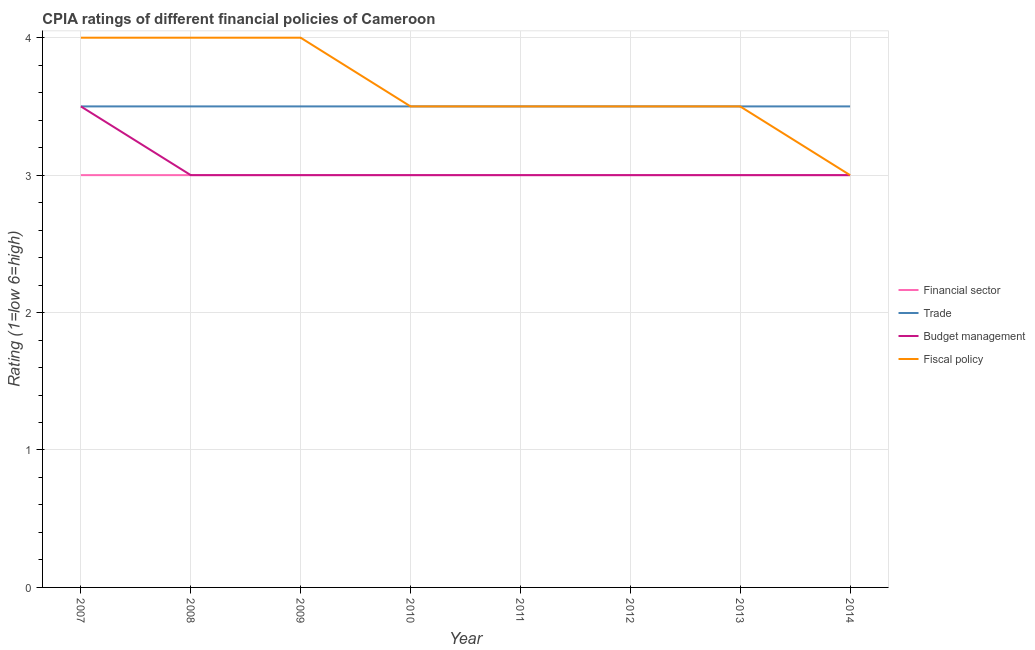How many different coloured lines are there?
Your answer should be very brief. 4. Is the number of lines equal to the number of legend labels?
Ensure brevity in your answer.  Yes. In which year was the cpia rating of financial sector minimum?
Ensure brevity in your answer.  2007. What is the total cpia rating of financial sector in the graph?
Your answer should be very brief. 24. What is the difference between the cpia rating of trade in 2011 and that in 2012?
Offer a terse response. 0. What is the difference between the cpia rating of fiscal policy in 2009 and the cpia rating of budget management in 2008?
Make the answer very short. 1. What is the average cpia rating of fiscal policy per year?
Give a very brief answer. 3.62. In the year 2011, what is the difference between the cpia rating of financial sector and cpia rating of fiscal policy?
Ensure brevity in your answer.  -0.5. In how many years, is the cpia rating of trade greater than 0.8?
Offer a very short reply. 8. What is the ratio of the cpia rating of trade in 2007 to that in 2014?
Provide a short and direct response. 1. Is the cpia rating of fiscal policy in 2007 less than that in 2014?
Offer a terse response. No. What is the difference between the highest and the second highest cpia rating of trade?
Ensure brevity in your answer.  0. Is it the case that in every year, the sum of the cpia rating of fiscal policy and cpia rating of trade is greater than the sum of cpia rating of financial sector and cpia rating of budget management?
Offer a very short reply. No. Is it the case that in every year, the sum of the cpia rating of financial sector and cpia rating of trade is greater than the cpia rating of budget management?
Your response must be concise. Yes. What is the difference between two consecutive major ticks on the Y-axis?
Offer a very short reply. 1. Are the values on the major ticks of Y-axis written in scientific E-notation?
Your answer should be compact. No. Does the graph contain grids?
Make the answer very short. Yes. Where does the legend appear in the graph?
Provide a short and direct response. Center right. How many legend labels are there?
Offer a terse response. 4. What is the title of the graph?
Keep it short and to the point. CPIA ratings of different financial policies of Cameroon. What is the label or title of the X-axis?
Keep it short and to the point. Year. What is the Rating (1=low 6=high) of Trade in 2007?
Keep it short and to the point. 3.5. What is the Rating (1=low 6=high) in Trade in 2008?
Give a very brief answer. 3.5. What is the Rating (1=low 6=high) in Budget management in 2008?
Offer a terse response. 3. What is the Rating (1=low 6=high) in Fiscal policy in 2008?
Keep it short and to the point. 4. What is the Rating (1=low 6=high) in Financial sector in 2009?
Your response must be concise. 3. What is the Rating (1=low 6=high) in Financial sector in 2010?
Provide a succinct answer. 3. What is the Rating (1=low 6=high) of Budget management in 2010?
Your answer should be very brief. 3. What is the Rating (1=low 6=high) in Fiscal policy in 2010?
Ensure brevity in your answer.  3.5. What is the Rating (1=low 6=high) in Trade in 2011?
Provide a succinct answer. 3.5. What is the Rating (1=low 6=high) in Budget management in 2011?
Make the answer very short. 3. What is the Rating (1=low 6=high) in Financial sector in 2012?
Your response must be concise. 3. What is the Rating (1=low 6=high) of Trade in 2012?
Give a very brief answer. 3.5. What is the Rating (1=low 6=high) in Fiscal policy in 2012?
Your response must be concise. 3.5. What is the Rating (1=low 6=high) of Trade in 2013?
Keep it short and to the point. 3.5. What is the Rating (1=low 6=high) of Fiscal policy in 2013?
Your answer should be very brief. 3.5. What is the Rating (1=low 6=high) in Trade in 2014?
Ensure brevity in your answer.  3.5. What is the Rating (1=low 6=high) in Budget management in 2014?
Offer a terse response. 3. Across all years, what is the minimum Rating (1=low 6=high) in Trade?
Ensure brevity in your answer.  3.5. Across all years, what is the minimum Rating (1=low 6=high) in Fiscal policy?
Ensure brevity in your answer.  3. What is the total Rating (1=low 6=high) of Financial sector in the graph?
Ensure brevity in your answer.  24. What is the total Rating (1=low 6=high) of Budget management in the graph?
Your answer should be compact. 24.5. What is the total Rating (1=low 6=high) in Fiscal policy in the graph?
Your answer should be compact. 29. What is the difference between the Rating (1=low 6=high) in Financial sector in 2007 and that in 2008?
Your answer should be compact. 0. What is the difference between the Rating (1=low 6=high) of Fiscal policy in 2007 and that in 2009?
Your response must be concise. 0. What is the difference between the Rating (1=low 6=high) of Fiscal policy in 2007 and that in 2010?
Give a very brief answer. 0.5. What is the difference between the Rating (1=low 6=high) of Financial sector in 2007 and that in 2011?
Provide a succinct answer. 0. What is the difference between the Rating (1=low 6=high) in Budget management in 2007 and that in 2011?
Give a very brief answer. 0.5. What is the difference between the Rating (1=low 6=high) of Financial sector in 2007 and that in 2012?
Your answer should be compact. 0. What is the difference between the Rating (1=low 6=high) in Budget management in 2007 and that in 2012?
Make the answer very short. 0.5. What is the difference between the Rating (1=low 6=high) of Fiscal policy in 2007 and that in 2012?
Your response must be concise. 0.5. What is the difference between the Rating (1=low 6=high) of Financial sector in 2007 and that in 2013?
Your answer should be very brief. 0. What is the difference between the Rating (1=low 6=high) of Financial sector in 2007 and that in 2014?
Your answer should be compact. 0. What is the difference between the Rating (1=low 6=high) in Fiscal policy in 2007 and that in 2014?
Keep it short and to the point. 1. What is the difference between the Rating (1=low 6=high) of Fiscal policy in 2008 and that in 2009?
Provide a succinct answer. 0. What is the difference between the Rating (1=low 6=high) in Financial sector in 2008 and that in 2010?
Offer a terse response. 0. What is the difference between the Rating (1=low 6=high) in Trade in 2008 and that in 2010?
Ensure brevity in your answer.  0. What is the difference between the Rating (1=low 6=high) in Budget management in 2008 and that in 2010?
Keep it short and to the point. 0. What is the difference between the Rating (1=low 6=high) in Trade in 2008 and that in 2011?
Your response must be concise. 0. What is the difference between the Rating (1=low 6=high) of Financial sector in 2008 and that in 2012?
Your answer should be compact. 0. What is the difference between the Rating (1=low 6=high) of Trade in 2008 and that in 2012?
Offer a terse response. 0. What is the difference between the Rating (1=low 6=high) in Budget management in 2008 and that in 2012?
Your answer should be compact. 0. What is the difference between the Rating (1=low 6=high) of Fiscal policy in 2008 and that in 2012?
Your answer should be very brief. 0.5. What is the difference between the Rating (1=low 6=high) of Trade in 2008 and that in 2013?
Offer a very short reply. 0. What is the difference between the Rating (1=low 6=high) of Fiscal policy in 2008 and that in 2013?
Ensure brevity in your answer.  0.5. What is the difference between the Rating (1=low 6=high) in Fiscal policy in 2008 and that in 2014?
Give a very brief answer. 1. What is the difference between the Rating (1=low 6=high) in Trade in 2009 and that in 2010?
Your answer should be compact. 0. What is the difference between the Rating (1=low 6=high) in Budget management in 2009 and that in 2010?
Keep it short and to the point. 0. What is the difference between the Rating (1=low 6=high) in Fiscal policy in 2009 and that in 2010?
Offer a terse response. 0.5. What is the difference between the Rating (1=low 6=high) in Financial sector in 2009 and that in 2011?
Make the answer very short. 0. What is the difference between the Rating (1=low 6=high) of Budget management in 2009 and that in 2011?
Your answer should be very brief. 0. What is the difference between the Rating (1=low 6=high) in Financial sector in 2009 and that in 2012?
Your answer should be compact. 0. What is the difference between the Rating (1=low 6=high) in Budget management in 2009 and that in 2012?
Offer a terse response. 0. What is the difference between the Rating (1=low 6=high) of Fiscal policy in 2009 and that in 2012?
Provide a short and direct response. 0.5. What is the difference between the Rating (1=low 6=high) in Budget management in 2009 and that in 2014?
Offer a terse response. 0. What is the difference between the Rating (1=low 6=high) in Financial sector in 2010 and that in 2011?
Provide a short and direct response. 0. What is the difference between the Rating (1=low 6=high) in Fiscal policy in 2010 and that in 2011?
Ensure brevity in your answer.  0. What is the difference between the Rating (1=low 6=high) of Trade in 2010 and that in 2012?
Offer a very short reply. 0. What is the difference between the Rating (1=low 6=high) in Budget management in 2010 and that in 2012?
Your answer should be very brief. 0. What is the difference between the Rating (1=low 6=high) in Financial sector in 2010 and that in 2013?
Your answer should be very brief. 0. What is the difference between the Rating (1=low 6=high) in Trade in 2010 and that in 2013?
Give a very brief answer. 0. What is the difference between the Rating (1=low 6=high) in Trade in 2011 and that in 2012?
Ensure brevity in your answer.  0. What is the difference between the Rating (1=low 6=high) in Fiscal policy in 2011 and that in 2012?
Ensure brevity in your answer.  0. What is the difference between the Rating (1=low 6=high) in Trade in 2011 and that in 2013?
Your answer should be very brief. 0. What is the difference between the Rating (1=low 6=high) in Fiscal policy in 2011 and that in 2014?
Your answer should be compact. 0.5. What is the difference between the Rating (1=low 6=high) of Financial sector in 2012 and that in 2013?
Provide a short and direct response. 0. What is the difference between the Rating (1=low 6=high) of Budget management in 2012 and that in 2013?
Make the answer very short. 0. What is the difference between the Rating (1=low 6=high) in Fiscal policy in 2012 and that in 2013?
Give a very brief answer. 0. What is the difference between the Rating (1=low 6=high) in Trade in 2012 and that in 2014?
Give a very brief answer. 0. What is the difference between the Rating (1=low 6=high) in Budget management in 2012 and that in 2014?
Offer a very short reply. 0. What is the difference between the Rating (1=low 6=high) of Fiscal policy in 2012 and that in 2014?
Make the answer very short. 0.5. What is the difference between the Rating (1=low 6=high) in Trade in 2013 and that in 2014?
Your response must be concise. 0. What is the difference between the Rating (1=low 6=high) of Financial sector in 2007 and the Rating (1=low 6=high) of Trade in 2008?
Your response must be concise. -0.5. What is the difference between the Rating (1=low 6=high) of Financial sector in 2007 and the Rating (1=low 6=high) of Budget management in 2008?
Keep it short and to the point. 0. What is the difference between the Rating (1=low 6=high) in Trade in 2007 and the Rating (1=low 6=high) in Fiscal policy in 2008?
Ensure brevity in your answer.  -0.5. What is the difference between the Rating (1=low 6=high) of Budget management in 2007 and the Rating (1=low 6=high) of Fiscal policy in 2008?
Make the answer very short. -0.5. What is the difference between the Rating (1=low 6=high) in Financial sector in 2007 and the Rating (1=low 6=high) in Trade in 2009?
Give a very brief answer. -0.5. What is the difference between the Rating (1=low 6=high) of Financial sector in 2007 and the Rating (1=low 6=high) of Budget management in 2009?
Ensure brevity in your answer.  0. What is the difference between the Rating (1=low 6=high) in Financial sector in 2007 and the Rating (1=low 6=high) in Fiscal policy in 2009?
Your answer should be compact. -1. What is the difference between the Rating (1=low 6=high) of Trade in 2007 and the Rating (1=low 6=high) of Budget management in 2009?
Ensure brevity in your answer.  0.5. What is the difference between the Rating (1=low 6=high) in Financial sector in 2007 and the Rating (1=low 6=high) in Trade in 2010?
Provide a succinct answer. -0.5. What is the difference between the Rating (1=low 6=high) of Financial sector in 2007 and the Rating (1=low 6=high) of Budget management in 2010?
Offer a very short reply. 0. What is the difference between the Rating (1=low 6=high) in Financial sector in 2007 and the Rating (1=low 6=high) in Fiscal policy in 2010?
Provide a succinct answer. -0.5. What is the difference between the Rating (1=low 6=high) of Trade in 2007 and the Rating (1=low 6=high) of Budget management in 2010?
Ensure brevity in your answer.  0.5. What is the difference between the Rating (1=low 6=high) in Trade in 2007 and the Rating (1=low 6=high) in Fiscal policy in 2010?
Ensure brevity in your answer.  0. What is the difference between the Rating (1=low 6=high) in Financial sector in 2007 and the Rating (1=low 6=high) in Trade in 2011?
Your response must be concise. -0.5. What is the difference between the Rating (1=low 6=high) of Financial sector in 2007 and the Rating (1=low 6=high) of Budget management in 2011?
Give a very brief answer. 0. What is the difference between the Rating (1=low 6=high) in Trade in 2007 and the Rating (1=low 6=high) in Budget management in 2011?
Provide a short and direct response. 0.5. What is the difference between the Rating (1=low 6=high) of Trade in 2007 and the Rating (1=low 6=high) of Fiscal policy in 2011?
Offer a terse response. 0. What is the difference between the Rating (1=low 6=high) in Financial sector in 2007 and the Rating (1=low 6=high) in Budget management in 2012?
Make the answer very short. 0. What is the difference between the Rating (1=low 6=high) of Budget management in 2007 and the Rating (1=low 6=high) of Fiscal policy in 2012?
Make the answer very short. 0. What is the difference between the Rating (1=low 6=high) in Financial sector in 2007 and the Rating (1=low 6=high) in Trade in 2013?
Your answer should be compact. -0.5. What is the difference between the Rating (1=low 6=high) in Financial sector in 2007 and the Rating (1=low 6=high) in Budget management in 2013?
Give a very brief answer. 0. What is the difference between the Rating (1=low 6=high) of Budget management in 2007 and the Rating (1=low 6=high) of Fiscal policy in 2013?
Make the answer very short. 0. What is the difference between the Rating (1=low 6=high) of Financial sector in 2007 and the Rating (1=low 6=high) of Trade in 2014?
Your answer should be very brief. -0.5. What is the difference between the Rating (1=low 6=high) in Trade in 2007 and the Rating (1=low 6=high) in Fiscal policy in 2014?
Ensure brevity in your answer.  0.5. What is the difference between the Rating (1=low 6=high) of Financial sector in 2008 and the Rating (1=low 6=high) of Fiscal policy in 2010?
Offer a terse response. -0.5. What is the difference between the Rating (1=low 6=high) in Financial sector in 2008 and the Rating (1=low 6=high) in Budget management in 2011?
Your response must be concise. 0. What is the difference between the Rating (1=low 6=high) of Financial sector in 2008 and the Rating (1=low 6=high) of Fiscal policy in 2011?
Offer a terse response. -0.5. What is the difference between the Rating (1=low 6=high) of Financial sector in 2008 and the Rating (1=low 6=high) of Trade in 2012?
Keep it short and to the point. -0.5. What is the difference between the Rating (1=low 6=high) in Financial sector in 2008 and the Rating (1=low 6=high) in Budget management in 2012?
Offer a terse response. 0. What is the difference between the Rating (1=low 6=high) of Financial sector in 2008 and the Rating (1=low 6=high) of Fiscal policy in 2012?
Provide a succinct answer. -0.5. What is the difference between the Rating (1=low 6=high) of Trade in 2008 and the Rating (1=low 6=high) of Fiscal policy in 2012?
Your answer should be very brief. 0. What is the difference between the Rating (1=low 6=high) in Financial sector in 2008 and the Rating (1=low 6=high) in Trade in 2013?
Offer a very short reply. -0.5. What is the difference between the Rating (1=low 6=high) in Financial sector in 2008 and the Rating (1=low 6=high) in Budget management in 2013?
Make the answer very short. 0. What is the difference between the Rating (1=low 6=high) of Financial sector in 2008 and the Rating (1=low 6=high) of Fiscal policy in 2013?
Offer a very short reply. -0.5. What is the difference between the Rating (1=low 6=high) in Trade in 2008 and the Rating (1=low 6=high) in Budget management in 2013?
Give a very brief answer. 0.5. What is the difference between the Rating (1=low 6=high) of Trade in 2008 and the Rating (1=low 6=high) of Fiscal policy in 2013?
Your answer should be very brief. 0. What is the difference between the Rating (1=low 6=high) of Budget management in 2008 and the Rating (1=low 6=high) of Fiscal policy in 2014?
Your response must be concise. 0. What is the difference between the Rating (1=low 6=high) in Financial sector in 2009 and the Rating (1=low 6=high) in Trade in 2010?
Give a very brief answer. -0.5. What is the difference between the Rating (1=low 6=high) in Financial sector in 2009 and the Rating (1=low 6=high) in Budget management in 2010?
Keep it short and to the point. 0. What is the difference between the Rating (1=low 6=high) in Financial sector in 2009 and the Rating (1=low 6=high) in Fiscal policy in 2010?
Ensure brevity in your answer.  -0.5. What is the difference between the Rating (1=low 6=high) in Trade in 2009 and the Rating (1=low 6=high) in Budget management in 2010?
Provide a succinct answer. 0.5. What is the difference between the Rating (1=low 6=high) in Trade in 2009 and the Rating (1=low 6=high) in Fiscal policy in 2010?
Provide a succinct answer. 0. What is the difference between the Rating (1=low 6=high) of Budget management in 2009 and the Rating (1=low 6=high) of Fiscal policy in 2010?
Your answer should be compact. -0.5. What is the difference between the Rating (1=low 6=high) of Financial sector in 2009 and the Rating (1=low 6=high) of Budget management in 2011?
Provide a succinct answer. 0. What is the difference between the Rating (1=low 6=high) in Trade in 2009 and the Rating (1=low 6=high) in Budget management in 2011?
Ensure brevity in your answer.  0.5. What is the difference between the Rating (1=low 6=high) in Trade in 2009 and the Rating (1=low 6=high) in Fiscal policy in 2011?
Provide a succinct answer. 0. What is the difference between the Rating (1=low 6=high) of Financial sector in 2009 and the Rating (1=low 6=high) of Trade in 2012?
Make the answer very short. -0.5. What is the difference between the Rating (1=low 6=high) in Financial sector in 2009 and the Rating (1=low 6=high) in Fiscal policy in 2012?
Keep it short and to the point. -0.5. What is the difference between the Rating (1=low 6=high) in Budget management in 2009 and the Rating (1=low 6=high) in Fiscal policy in 2012?
Give a very brief answer. -0.5. What is the difference between the Rating (1=low 6=high) of Trade in 2009 and the Rating (1=low 6=high) of Fiscal policy in 2013?
Your answer should be compact. 0. What is the difference between the Rating (1=low 6=high) of Budget management in 2009 and the Rating (1=low 6=high) of Fiscal policy in 2013?
Provide a succinct answer. -0.5. What is the difference between the Rating (1=low 6=high) in Financial sector in 2009 and the Rating (1=low 6=high) in Trade in 2014?
Make the answer very short. -0.5. What is the difference between the Rating (1=low 6=high) of Financial sector in 2009 and the Rating (1=low 6=high) of Fiscal policy in 2014?
Your response must be concise. 0. What is the difference between the Rating (1=low 6=high) of Financial sector in 2010 and the Rating (1=low 6=high) of Trade in 2011?
Give a very brief answer. -0.5. What is the difference between the Rating (1=low 6=high) of Financial sector in 2010 and the Rating (1=low 6=high) of Budget management in 2012?
Provide a succinct answer. 0. What is the difference between the Rating (1=low 6=high) in Trade in 2010 and the Rating (1=low 6=high) in Budget management in 2012?
Provide a succinct answer. 0.5. What is the difference between the Rating (1=low 6=high) in Trade in 2010 and the Rating (1=low 6=high) in Fiscal policy in 2012?
Your answer should be compact. 0. What is the difference between the Rating (1=low 6=high) in Financial sector in 2010 and the Rating (1=low 6=high) in Trade in 2013?
Provide a short and direct response. -0.5. What is the difference between the Rating (1=low 6=high) in Trade in 2010 and the Rating (1=low 6=high) in Fiscal policy in 2013?
Your answer should be very brief. 0. What is the difference between the Rating (1=low 6=high) in Trade in 2010 and the Rating (1=low 6=high) in Budget management in 2014?
Provide a succinct answer. 0.5. What is the difference between the Rating (1=low 6=high) in Financial sector in 2011 and the Rating (1=low 6=high) in Trade in 2012?
Your answer should be very brief. -0.5. What is the difference between the Rating (1=low 6=high) of Financial sector in 2011 and the Rating (1=low 6=high) of Budget management in 2012?
Offer a terse response. 0. What is the difference between the Rating (1=low 6=high) in Financial sector in 2011 and the Rating (1=low 6=high) in Fiscal policy in 2012?
Provide a succinct answer. -0.5. What is the difference between the Rating (1=low 6=high) in Trade in 2011 and the Rating (1=low 6=high) in Fiscal policy in 2012?
Make the answer very short. 0. What is the difference between the Rating (1=low 6=high) in Budget management in 2011 and the Rating (1=low 6=high) in Fiscal policy in 2012?
Provide a short and direct response. -0.5. What is the difference between the Rating (1=low 6=high) of Financial sector in 2011 and the Rating (1=low 6=high) of Trade in 2013?
Offer a terse response. -0.5. What is the difference between the Rating (1=low 6=high) of Financial sector in 2011 and the Rating (1=low 6=high) of Budget management in 2013?
Your response must be concise. 0. What is the difference between the Rating (1=low 6=high) of Financial sector in 2011 and the Rating (1=low 6=high) of Fiscal policy in 2013?
Your response must be concise. -0.5. What is the difference between the Rating (1=low 6=high) in Financial sector in 2011 and the Rating (1=low 6=high) in Budget management in 2014?
Your answer should be compact. 0. What is the difference between the Rating (1=low 6=high) in Trade in 2011 and the Rating (1=low 6=high) in Budget management in 2014?
Your answer should be very brief. 0.5. What is the difference between the Rating (1=low 6=high) of Trade in 2011 and the Rating (1=low 6=high) of Fiscal policy in 2014?
Keep it short and to the point. 0.5. What is the difference between the Rating (1=low 6=high) of Financial sector in 2012 and the Rating (1=low 6=high) of Budget management in 2013?
Your answer should be compact. 0. What is the difference between the Rating (1=low 6=high) of Trade in 2012 and the Rating (1=low 6=high) of Budget management in 2013?
Keep it short and to the point. 0.5. What is the difference between the Rating (1=low 6=high) of Trade in 2012 and the Rating (1=low 6=high) of Fiscal policy in 2013?
Ensure brevity in your answer.  0. What is the difference between the Rating (1=low 6=high) in Budget management in 2012 and the Rating (1=low 6=high) in Fiscal policy in 2013?
Provide a succinct answer. -0.5. What is the difference between the Rating (1=low 6=high) of Financial sector in 2012 and the Rating (1=low 6=high) of Trade in 2014?
Keep it short and to the point. -0.5. What is the difference between the Rating (1=low 6=high) of Financial sector in 2012 and the Rating (1=low 6=high) of Fiscal policy in 2014?
Offer a very short reply. 0. What is the difference between the Rating (1=low 6=high) of Financial sector in 2013 and the Rating (1=low 6=high) of Trade in 2014?
Provide a succinct answer. -0.5. What is the difference between the Rating (1=low 6=high) in Financial sector in 2013 and the Rating (1=low 6=high) in Fiscal policy in 2014?
Your answer should be compact. 0. What is the difference between the Rating (1=low 6=high) of Trade in 2013 and the Rating (1=low 6=high) of Budget management in 2014?
Offer a terse response. 0.5. What is the average Rating (1=low 6=high) of Financial sector per year?
Provide a succinct answer. 3. What is the average Rating (1=low 6=high) of Trade per year?
Your answer should be compact. 3.5. What is the average Rating (1=low 6=high) in Budget management per year?
Your response must be concise. 3.06. What is the average Rating (1=low 6=high) of Fiscal policy per year?
Provide a succinct answer. 3.62. In the year 2007, what is the difference between the Rating (1=low 6=high) of Financial sector and Rating (1=low 6=high) of Trade?
Offer a terse response. -0.5. In the year 2007, what is the difference between the Rating (1=low 6=high) in Financial sector and Rating (1=low 6=high) in Budget management?
Provide a short and direct response. -0.5. In the year 2007, what is the difference between the Rating (1=low 6=high) of Financial sector and Rating (1=low 6=high) of Fiscal policy?
Make the answer very short. -1. In the year 2007, what is the difference between the Rating (1=low 6=high) in Trade and Rating (1=low 6=high) in Budget management?
Your answer should be very brief. 0. In the year 2008, what is the difference between the Rating (1=low 6=high) of Financial sector and Rating (1=low 6=high) of Trade?
Offer a very short reply. -0.5. In the year 2008, what is the difference between the Rating (1=low 6=high) in Financial sector and Rating (1=low 6=high) in Budget management?
Make the answer very short. 0. In the year 2008, what is the difference between the Rating (1=low 6=high) in Trade and Rating (1=low 6=high) in Budget management?
Provide a succinct answer. 0.5. In the year 2008, what is the difference between the Rating (1=low 6=high) in Trade and Rating (1=low 6=high) in Fiscal policy?
Provide a short and direct response. -0.5. In the year 2009, what is the difference between the Rating (1=low 6=high) in Financial sector and Rating (1=low 6=high) in Trade?
Your response must be concise. -0.5. In the year 2010, what is the difference between the Rating (1=low 6=high) of Financial sector and Rating (1=low 6=high) of Budget management?
Ensure brevity in your answer.  0. In the year 2010, what is the difference between the Rating (1=low 6=high) of Trade and Rating (1=low 6=high) of Fiscal policy?
Provide a short and direct response. 0. In the year 2011, what is the difference between the Rating (1=low 6=high) of Budget management and Rating (1=low 6=high) of Fiscal policy?
Ensure brevity in your answer.  -0.5. In the year 2012, what is the difference between the Rating (1=low 6=high) in Financial sector and Rating (1=low 6=high) in Trade?
Offer a terse response. -0.5. In the year 2012, what is the difference between the Rating (1=low 6=high) in Financial sector and Rating (1=low 6=high) in Budget management?
Provide a succinct answer. 0. In the year 2012, what is the difference between the Rating (1=low 6=high) of Financial sector and Rating (1=low 6=high) of Fiscal policy?
Give a very brief answer. -0.5. In the year 2012, what is the difference between the Rating (1=low 6=high) of Trade and Rating (1=low 6=high) of Budget management?
Provide a succinct answer. 0.5. In the year 2012, what is the difference between the Rating (1=low 6=high) of Trade and Rating (1=low 6=high) of Fiscal policy?
Ensure brevity in your answer.  0. In the year 2012, what is the difference between the Rating (1=low 6=high) of Budget management and Rating (1=low 6=high) of Fiscal policy?
Make the answer very short. -0.5. In the year 2013, what is the difference between the Rating (1=low 6=high) of Trade and Rating (1=low 6=high) of Budget management?
Offer a very short reply. 0.5. In the year 2014, what is the difference between the Rating (1=low 6=high) of Financial sector and Rating (1=low 6=high) of Budget management?
Make the answer very short. 0. In the year 2014, what is the difference between the Rating (1=low 6=high) in Trade and Rating (1=low 6=high) in Budget management?
Offer a very short reply. 0.5. In the year 2014, what is the difference between the Rating (1=low 6=high) in Trade and Rating (1=low 6=high) in Fiscal policy?
Provide a short and direct response. 0.5. What is the ratio of the Rating (1=low 6=high) of Trade in 2007 to that in 2008?
Your answer should be very brief. 1. What is the ratio of the Rating (1=low 6=high) of Budget management in 2007 to that in 2008?
Keep it short and to the point. 1.17. What is the ratio of the Rating (1=low 6=high) in Trade in 2007 to that in 2009?
Ensure brevity in your answer.  1. What is the ratio of the Rating (1=low 6=high) of Budget management in 2007 to that in 2009?
Provide a succinct answer. 1.17. What is the ratio of the Rating (1=low 6=high) of Fiscal policy in 2007 to that in 2009?
Offer a terse response. 1. What is the ratio of the Rating (1=low 6=high) of Financial sector in 2007 to that in 2010?
Ensure brevity in your answer.  1. What is the ratio of the Rating (1=low 6=high) of Trade in 2007 to that in 2010?
Offer a very short reply. 1. What is the ratio of the Rating (1=low 6=high) in Budget management in 2007 to that in 2010?
Keep it short and to the point. 1.17. What is the ratio of the Rating (1=low 6=high) of Financial sector in 2007 to that in 2011?
Your response must be concise. 1. What is the ratio of the Rating (1=low 6=high) in Trade in 2007 to that in 2011?
Offer a very short reply. 1. What is the ratio of the Rating (1=low 6=high) in Budget management in 2007 to that in 2011?
Your response must be concise. 1.17. What is the ratio of the Rating (1=low 6=high) of Trade in 2007 to that in 2012?
Ensure brevity in your answer.  1. What is the ratio of the Rating (1=low 6=high) of Fiscal policy in 2007 to that in 2012?
Your answer should be compact. 1.14. What is the ratio of the Rating (1=low 6=high) of Trade in 2007 to that in 2013?
Offer a very short reply. 1. What is the ratio of the Rating (1=low 6=high) of Budget management in 2007 to that in 2013?
Ensure brevity in your answer.  1.17. What is the ratio of the Rating (1=low 6=high) in Financial sector in 2008 to that in 2009?
Provide a short and direct response. 1. What is the ratio of the Rating (1=low 6=high) of Trade in 2008 to that in 2009?
Offer a terse response. 1. What is the ratio of the Rating (1=low 6=high) of Trade in 2008 to that in 2010?
Your answer should be compact. 1. What is the ratio of the Rating (1=low 6=high) of Trade in 2008 to that in 2011?
Offer a very short reply. 1. What is the ratio of the Rating (1=low 6=high) in Budget management in 2008 to that in 2011?
Your response must be concise. 1. What is the ratio of the Rating (1=low 6=high) in Fiscal policy in 2008 to that in 2011?
Your answer should be very brief. 1.14. What is the ratio of the Rating (1=low 6=high) in Budget management in 2008 to that in 2012?
Provide a short and direct response. 1. What is the ratio of the Rating (1=low 6=high) of Fiscal policy in 2008 to that in 2012?
Make the answer very short. 1.14. What is the ratio of the Rating (1=low 6=high) of Fiscal policy in 2008 to that in 2013?
Provide a succinct answer. 1.14. What is the ratio of the Rating (1=low 6=high) of Financial sector in 2008 to that in 2014?
Provide a succinct answer. 1. What is the ratio of the Rating (1=low 6=high) of Trade in 2008 to that in 2014?
Provide a succinct answer. 1. What is the ratio of the Rating (1=low 6=high) of Financial sector in 2009 to that in 2010?
Keep it short and to the point. 1. What is the ratio of the Rating (1=low 6=high) of Budget management in 2009 to that in 2010?
Make the answer very short. 1. What is the ratio of the Rating (1=low 6=high) of Financial sector in 2009 to that in 2011?
Make the answer very short. 1. What is the ratio of the Rating (1=low 6=high) in Budget management in 2009 to that in 2011?
Keep it short and to the point. 1. What is the ratio of the Rating (1=low 6=high) in Fiscal policy in 2009 to that in 2011?
Give a very brief answer. 1.14. What is the ratio of the Rating (1=low 6=high) in Financial sector in 2009 to that in 2012?
Make the answer very short. 1. What is the ratio of the Rating (1=low 6=high) in Budget management in 2009 to that in 2012?
Your response must be concise. 1. What is the ratio of the Rating (1=low 6=high) in Financial sector in 2009 to that in 2013?
Ensure brevity in your answer.  1. What is the ratio of the Rating (1=low 6=high) of Trade in 2009 to that in 2013?
Offer a terse response. 1. What is the ratio of the Rating (1=low 6=high) in Budget management in 2009 to that in 2013?
Ensure brevity in your answer.  1. What is the ratio of the Rating (1=low 6=high) in Fiscal policy in 2009 to that in 2013?
Your answer should be very brief. 1.14. What is the ratio of the Rating (1=low 6=high) in Fiscal policy in 2009 to that in 2014?
Give a very brief answer. 1.33. What is the ratio of the Rating (1=low 6=high) of Financial sector in 2010 to that in 2011?
Make the answer very short. 1. What is the ratio of the Rating (1=low 6=high) in Financial sector in 2010 to that in 2012?
Offer a very short reply. 1. What is the ratio of the Rating (1=low 6=high) in Fiscal policy in 2010 to that in 2012?
Ensure brevity in your answer.  1. What is the ratio of the Rating (1=low 6=high) in Budget management in 2010 to that in 2014?
Your response must be concise. 1. What is the ratio of the Rating (1=low 6=high) of Fiscal policy in 2010 to that in 2014?
Offer a very short reply. 1.17. What is the ratio of the Rating (1=low 6=high) in Fiscal policy in 2011 to that in 2012?
Make the answer very short. 1. What is the ratio of the Rating (1=low 6=high) of Financial sector in 2011 to that in 2013?
Your answer should be compact. 1. What is the ratio of the Rating (1=low 6=high) of Trade in 2011 to that in 2013?
Your answer should be very brief. 1. What is the ratio of the Rating (1=low 6=high) of Budget management in 2011 to that in 2013?
Ensure brevity in your answer.  1. What is the ratio of the Rating (1=low 6=high) in Fiscal policy in 2011 to that in 2013?
Your response must be concise. 1. What is the ratio of the Rating (1=low 6=high) of Trade in 2011 to that in 2014?
Provide a short and direct response. 1. What is the ratio of the Rating (1=low 6=high) in Budget management in 2011 to that in 2014?
Make the answer very short. 1. What is the ratio of the Rating (1=low 6=high) in Fiscal policy in 2011 to that in 2014?
Keep it short and to the point. 1.17. What is the ratio of the Rating (1=low 6=high) of Trade in 2012 to that in 2013?
Your answer should be compact. 1. What is the ratio of the Rating (1=low 6=high) of Budget management in 2012 to that in 2013?
Your response must be concise. 1. What is the ratio of the Rating (1=low 6=high) of Fiscal policy in 2012 to that in 2013?
Your answer should be very brief. 1. What is the ratio of the Rating (1=low 6=high) of Budget management in 2012 to that in 2014?
Make the answer very short. 1. What is the ratio of the Rating (1=low 6=high) of Fiscal policy in 2012 to that in 2014?
Your answer should be very brief. 1.17. What is the ratio of the Rating (1=low 6=high) of Financial sector in 2013 to that in 2014?
Make the answer very short. 1. What is the ratio of the Rating (1=low 6=high) in Budget management in 2013 to that in 2014?
Provide a short and direct response. 1. What is the difference between the highest and the second highest Rating (1=low 6=high) in Financial sector?
Give a very brief answer. 0. What is the difference between the highest and the second highest Rating (1=low 6=high) in Trade?
Provide a short and direct response. 0. What is the difference between the highest and the second highest Rating (1=low 6=high) of Budget management?
Your response must be concise. 0.5. What is the difference between the highest and the second highest Rating (1=low 6=high) in Fiscal policy?
Ensure brevity in your answer.  0. 